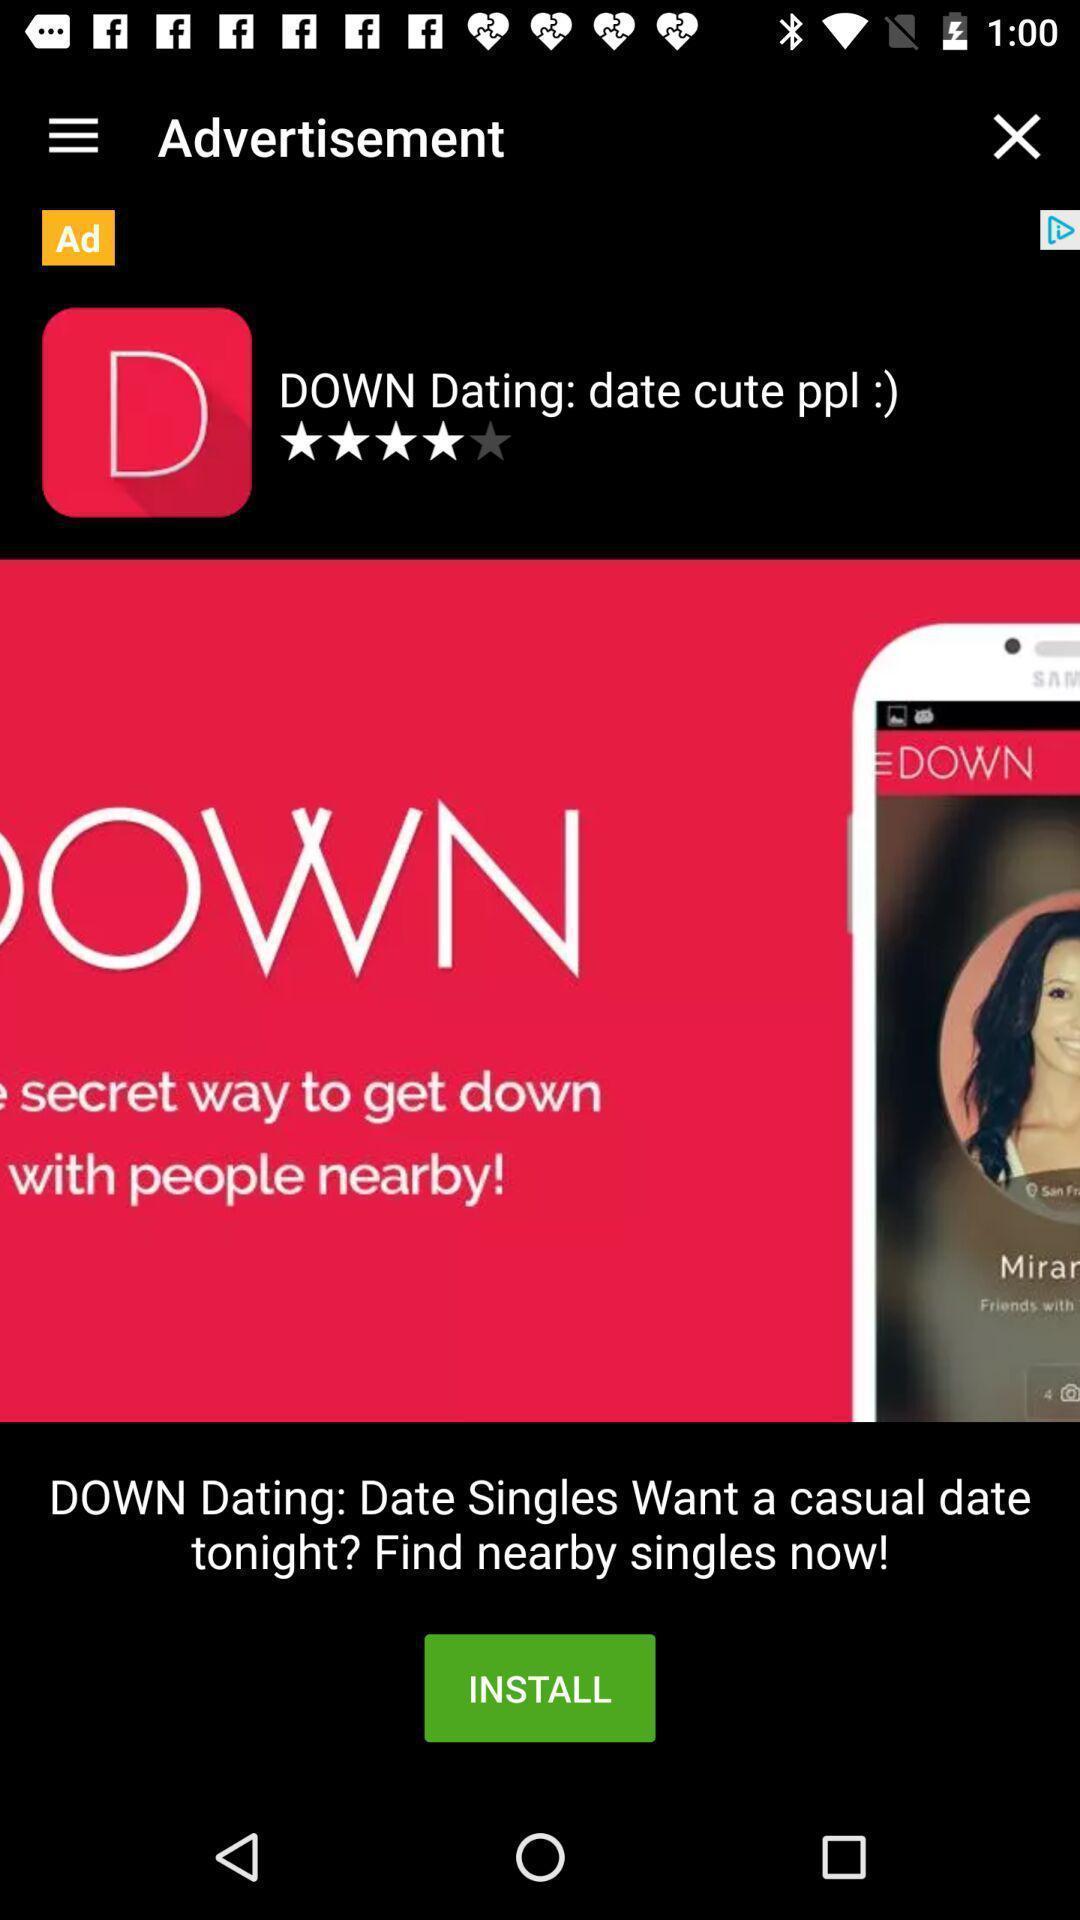Provide a detailed account of this screenshot. Screen shows installation details in a advertisement. 